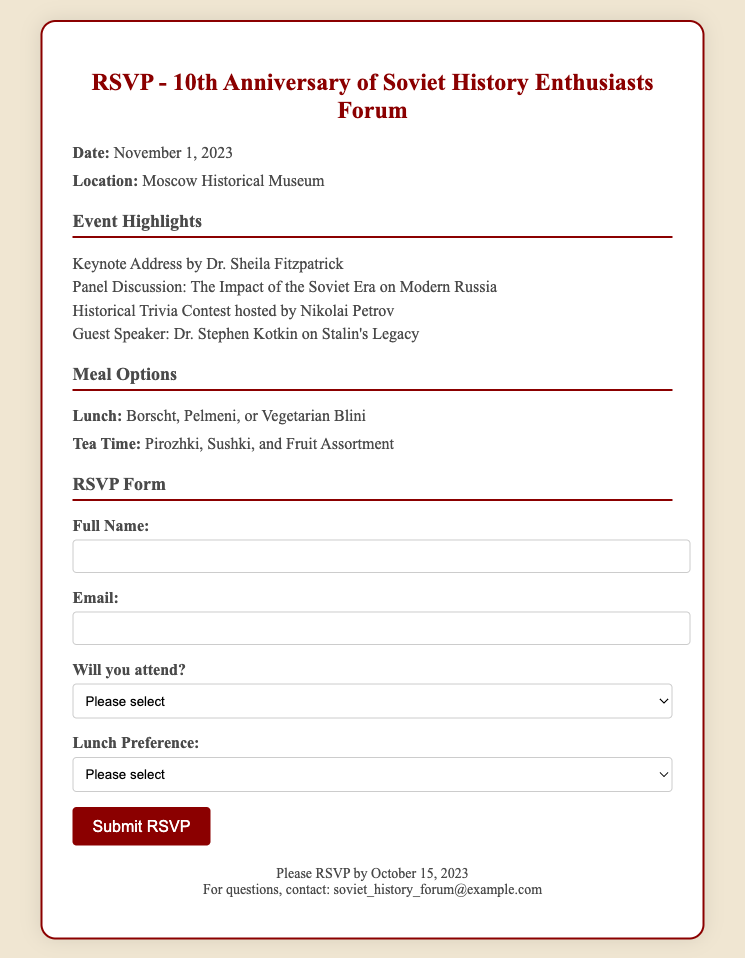What is the date of the event? The date of the event is mentioned in the document as November 1, 2023.
Answer: November 1, 2023 Who is the keynote speaker? The details of the keynote address specify Dr. Sheila Fitzpatrick as the keynote speaker for the event.
Answer: Dr. Sheila Fitzpatrick Where is the location of the celebration? The location of the event is stated in the document as Moscow Historical Museum.
Answer: Moscow Historical Museum What meal options are available for lunch? The document lists the available lunch options as Borscht, Pelmeni, or Vegetarian Blini.
Answer: Borscht, Pelmeni, Vegetarian Blini What is the deadline to RSVP? The document indicates that RSVP should be submitted by October 15, 2023.
Answer: October 15, 2023 Who is hosting the historical trivia contest? The document specifies that Nikolai Petrov will be hosting the historical trivia contest.
Answer: Nikolai Petrov Which guest speaker will talk about Stalin's legacy? The document mentions that Dr. Stephen Kotkin will speak about Stalin's Legacy.
Answer: Dr. Stephen Kotkin What type of event is this document representing? The document is an RSVP card for the 10th Anniversary celebration of the Soviet History Enthusiasts Forum.
Answer: RSVP card Which option does not have a meal preference listed? The document states "Please select" as the open option for meal preference, indicating that no specific meal has been chosen.
Answer: Please select 